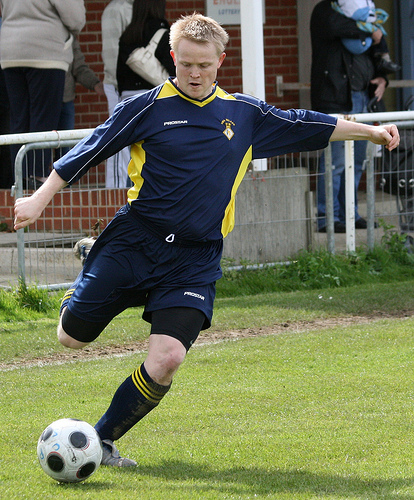<image>
Is the soccer player in front of the soccer ball? No. The soccer player is not in front of the soccer ball. The spatial positioning shows a different relationship between these objects. 